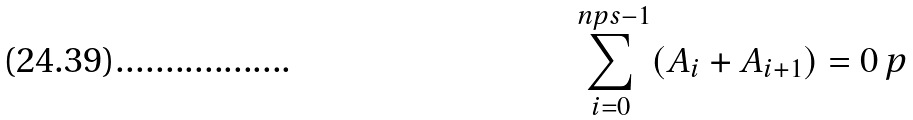Convert formula to latex. <formula><loc_0><loc_0><loc_500><loc_500>\sum _ { i = 0 } ^ { \ n p s - 1 } ( A _ { i } + A _ { i + 1 } ) = 0 \ p</formula> 